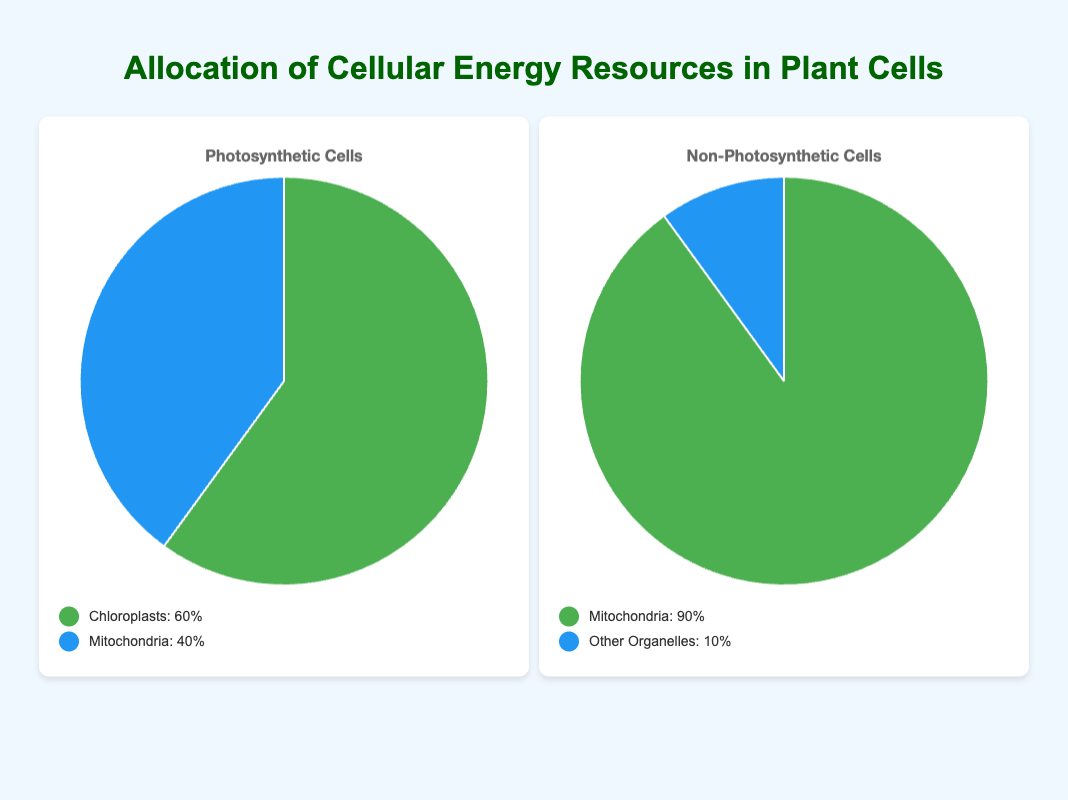Which entity in photosynthetic cells receives the highest percentage of cellular energy resources? The figure shows that in photosynthetic cells, chloroplasts receive 60% of the energy resources, which is the highest percentage.
Answer: Chloroplasts What's the difference in the percentage of cellular energy resources allocated to mitochondria in photosynthetic cells compared to non-photosynthetic cells? Photosynthetic cells allocate 40% of energy to mitochondria, whereas non-photosynthetic cells allocate 90%. The difference is 90% - 40% = 50%.
Answer: 50% Which type of cell allocates a larger percentage of energy to "Other Organelles"? According to the figure, only non-photosynthetic cells allocate energy to "Other Organelles," and this allocation is 10%. Photosynthetic cells do not allocate any energy to "Other Organelles."
Answer: Non-Photosynthetic Cells What is the combined percentage of energy resources allocated to mitochondria in both photosynthetic and non-photosynthetic cells? Photosynthetic cells allocate 40% and non-photosynthetic cells allocate 90% to mitochondria. The combined percentage is 40% + 90% = 130%.
Answer: 130% In photosynthetic cells, what is the ratio of energy allocation between chloroplasts and mitochondria? The energy allocation for chloroplasts is 60% and for mitochondria is 40%. The ratio is 60:40, which simplifies to 3:2.
Answer: 3:2 Which cell type has a more diversified distribution of energy resources? Photosynthetic cells distribute energy between chloroplasts and mitochondria (60% and 40%), while non-photosynthetic cells distribute energy mainly to mitochondria (90%) and a small portion to "Other Organelles" (10%). Photosynthetic cells show a more balanced distribution compared to the highly skewed distribution in non-photosynthetic cells.
Answer: Photosynthetic Cells If you were to double the energy allocation of mitochondria in non-photosynthetic cells, what would be its new percentage? Currently, mitochondria in non-photosynthetic cells receive 90% of the energy. If this allocation is doubled, it would be 90% * 2 = 180%. However, since percentages cannot exceed 100%, this scenario is practically impossible but theoretically would be 180%.
Answer: 180% What fraction of the total energy resources in non-photosynthetic cells is allocated to entities other than mitochondria? Non-photosynthetic cells allocate 10% of their energy resources to "Other Organelles." Therefore, the fraction is 10/100, which simplifies to 1/10.
Answer: 1/10 